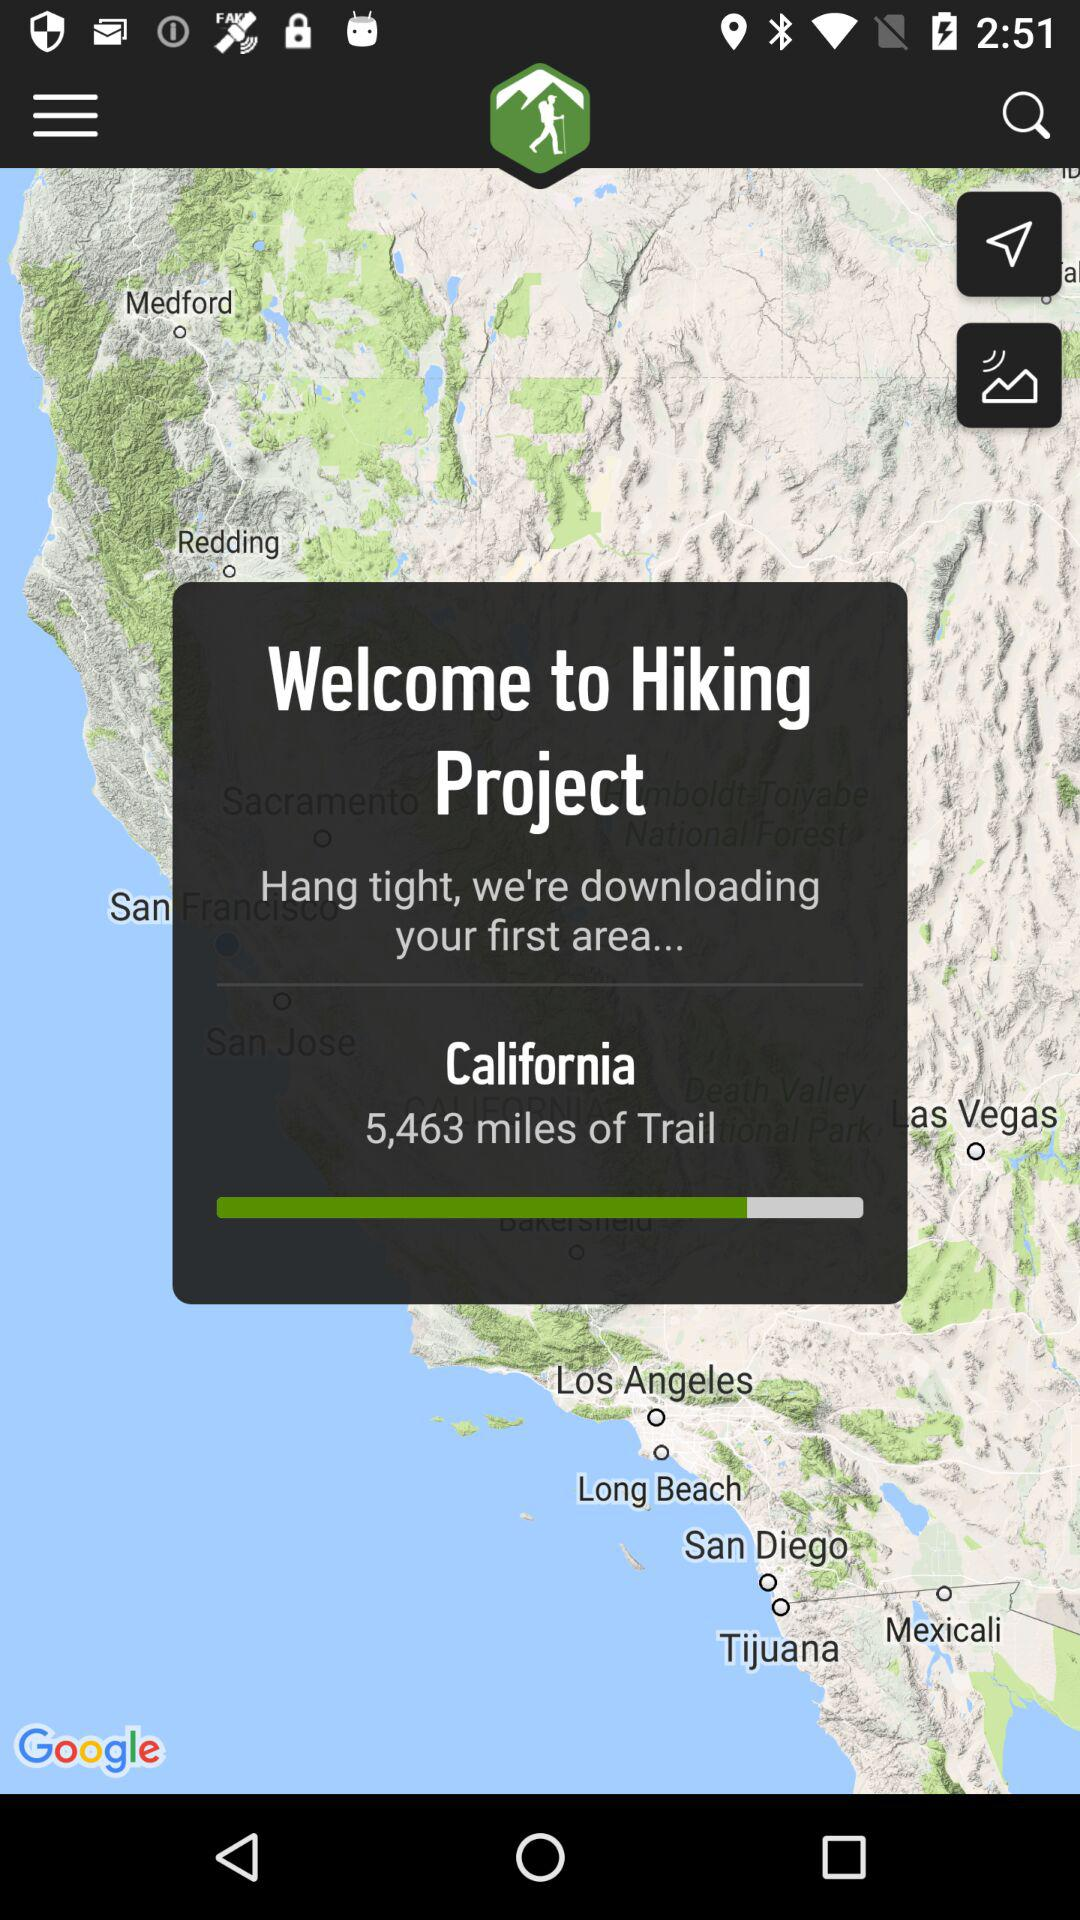What state is mentioned on the pop-up? The mentioned state is California. 